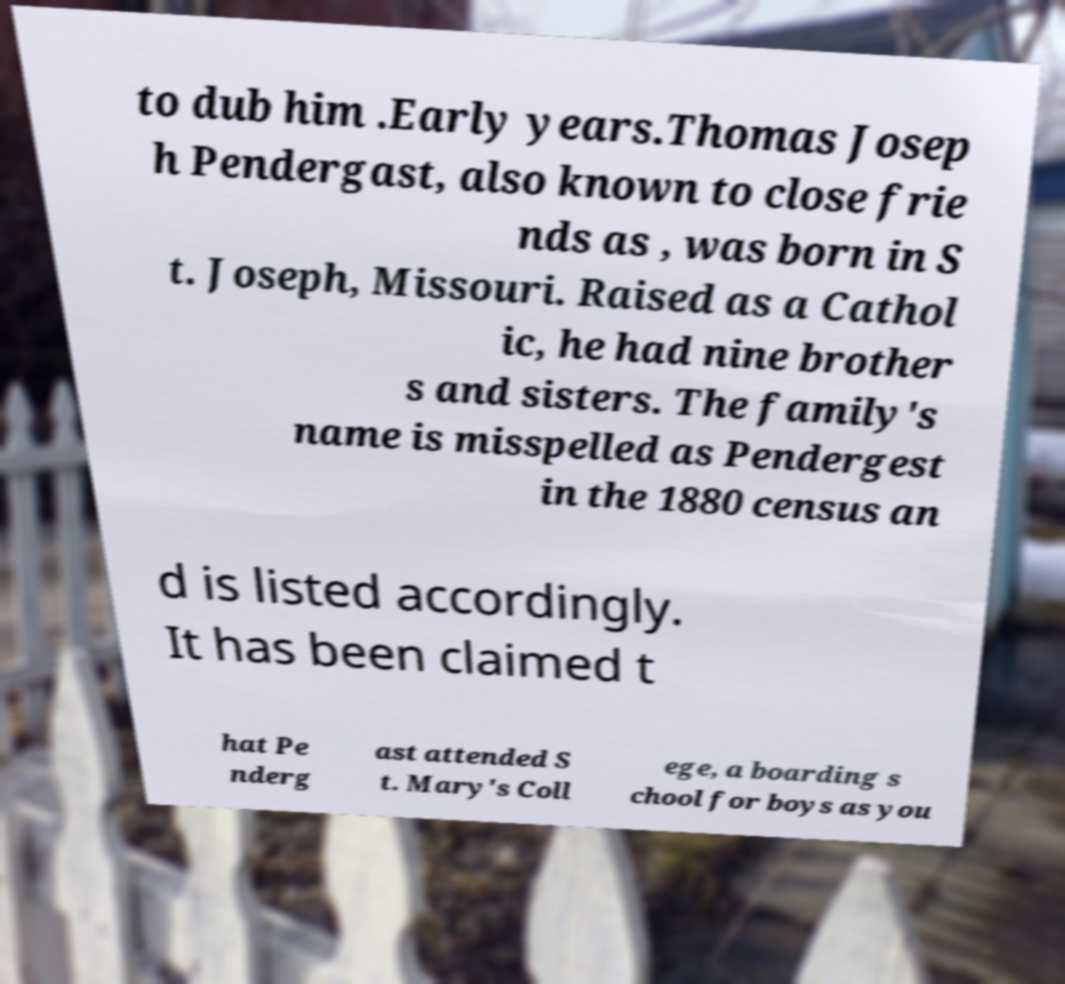Please read and relay the text visible in this image. What does it say? to dub him .Early years.Thomas Josep h Pendergast, also known to close frie nds as , was born in S t. Joseph, Missouri. Raised as a Cathol ic, he had nine brother s and sisters. The family's name is misspelled as Pendergest in the 1880 census an d is listed accordingly. It has been claimed t hat Pe nderg ast attended S t. Mary's Coll ege, a boarding s chool for boys as you 